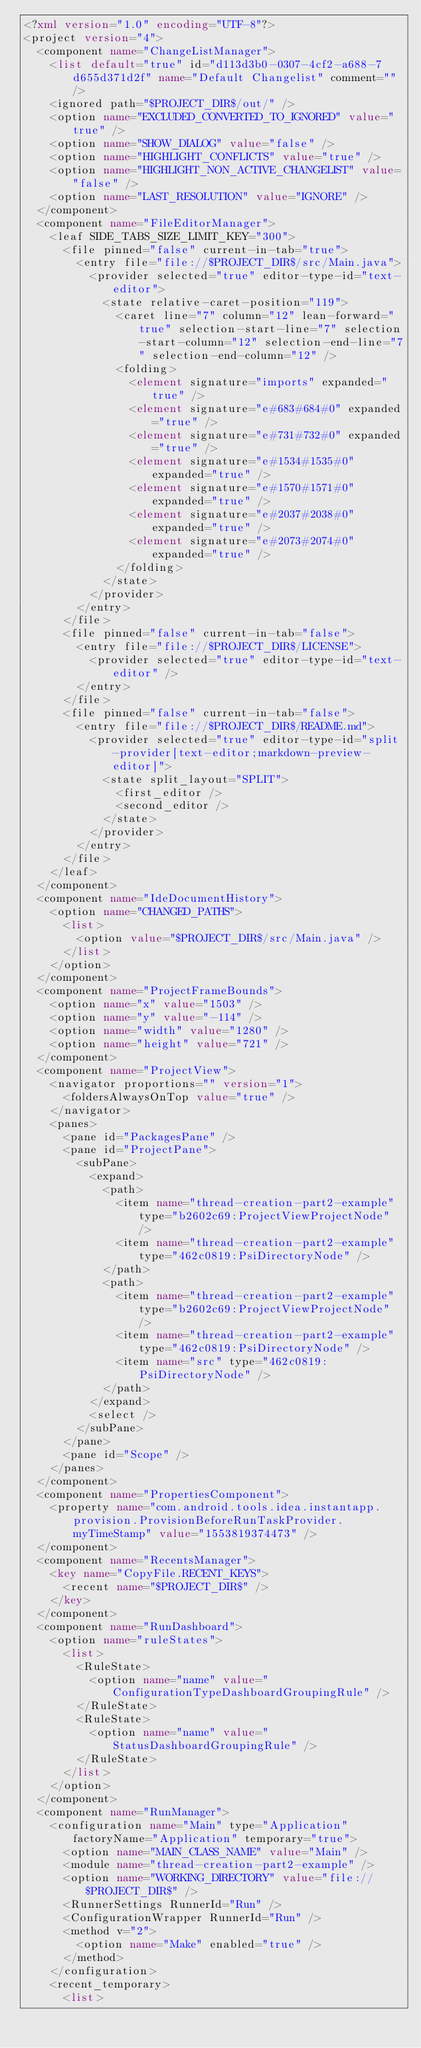<code> <loc_0><loc_0><loc_500><loc_500><_XML_><?xml version="1.0" encoding="UTF-8"?>
<project version="4">
  <component name="ChangeListManager">
    <list default="true" id="d113d3b0-0307-4cf2-a688-7d655d371d2f" name="Default Changelist" comment="" />
    <ignored path="$PROJECT_DIR$/out/" />
    <option name="EXCLUDED_CONVERTED_TO_IGNORED" value="true" />
    <option name="SHOW_DIALOG" value="false" />
    <option name="HIGHLIGHT_CONFLICTS" value="true" />
    <option name="HIGHLIGHT_NON_ACTIVE_CHANGELIST" value="false" />
    <option name="LAST_RESOLUTION" value="IGNORE" />
  </component>
  <component name="FileEditorManager">
    <leaf SIDE_TABS_SIZE_LIMIT_KEY="300">
      <file pinned="false" current-in-tab="true">
        <entry file="file://$PROJECT_DIR$/src/Main.java">
          <provider selected="true" editor-type-id="text-editor">
            <state relative-caret-position="119">
              <caret line="7" column="12" lean-forward="true" selection-start-line="7" selection-start-column="12" selection-end-line="7" selection-end-column="12" />
              <folding>
                <element signature="imports" expanded="true" />
                <element signature="e#683#684#0" expanded="true" />
                <element signature="e#731#732#0" expanded="true" />
                <element signature="e#1534#1535#0" expanded="true" />
                <element signature="e#1570#1571#0" expanded="true" />
                <element signature="e#2037#2038#0" expanded="true" />
                <element signature="e#2073#2074#0" expanded="true" />
              </folding>
            </state>
          </provider>
        </entry>
      </file>
      <file pinned="false" current-in-tab="false">
        <entry file="file://$PROJECT_DIR$/LICENSE">
          <provider selected="true" editor-type-id="text-editor" />
        </entry>
      </file>
      <file pinned="false" current-in-tab="false">
        <entry file="file://$PROJECT_DIR$/README.md">
          <provider selected="true" editor-type-id="split-provider[text-editor;markdown-preview-editor]">
            <state split_layout="SPLIT">
              <first_editor />
              <second_editor />
            </state>
          </provider>
        </entry>
      </file>
    </leaf>
  </component>
  <component name="IdeDocumentHistory">
    <option name="CHANGED_PATHS">
      <list>
        <option value="$PROJECT_DIR$/src/Main.java" />
      </list>
    </option>
  </component>
  <component name="ProjectFrameBounds">
    <option name="x" value="1503" />
    <option name="y" value="-114" />
    <option name="width" value="1280" />
    <option name="height" value="721" />
  </component>
  <component name="ProjectView">
    <navigator proportions="" version="1">
      <foldersAlwaysOnTop value="true" />
    </navigator>
    <panes>
      <pane id="PackagesPane" />
      <pane id="ProjectPane">
        <subPane>
          <expand>
            <path>
              <item name="thread-creation-part2-example" type="b2602c69:ProjectViewProjectNode" />
              <item name="thread-creation-part2-example" type="462c0819:PsiDirectoryNode" />
            </path>
            <path>
              <item name="thread-creation-part2-example" type="b2602c69:ProjectViewProjectNode" />
              <item name="thread-creation-part2-example" type="462c0819:PsiDirectoryNode" />
              <item name="src" type="462c0819:PsiDirectoryNode" />
            </path>
          </expand>
          <select />
        </subPane>
      </pane>
      <pane id="Scope" />
    </panes>
  </component>
  <component name="PropertiesComponent">
    <property name="com.android.tools.idea.instantapp.provision.ProvisionBeforeRunTaskProvider.myTimeStamp" value="1553819374473" />
  </component>
  <component name="RecentsManager">
    <key name="CopyFile.RECENT_KEYS">
      <recent name="$PROJECT_DIR$" />
    </key>
  </component>
  <component name="RunDashboard">
    <option name="ruleStates">
      <list>
        <RuleState>
          <option name="name" value="ConfigurationTypeDashboardGroupingRule" />
        </RuleState>
        <RuleState>
          <option name="name" value="StatusDashboardGroupingRule" />
        </RuleState>
      </list>
    </option>
  </component>
  <component name="RunManager">
    <configuration name="Main" type="Application" factoryName="Application" temporary="true">
      <option name="MAIN_CLASS_NAME" value="Main" />
      <module name="thread-creation-part2-example" />
      <option name="WORKING_DIRECTORY" value="file://$PROJECT_DIR$" />
      <RunnerSettings RunnerId="Run" />
      <ConfigurationWrapper RunnerId="Run" />
      <method v="2">
        <option name="Make" enabled="true" />
      </method>
    </configuration>
    <recent_temporary>
      <list></code> 